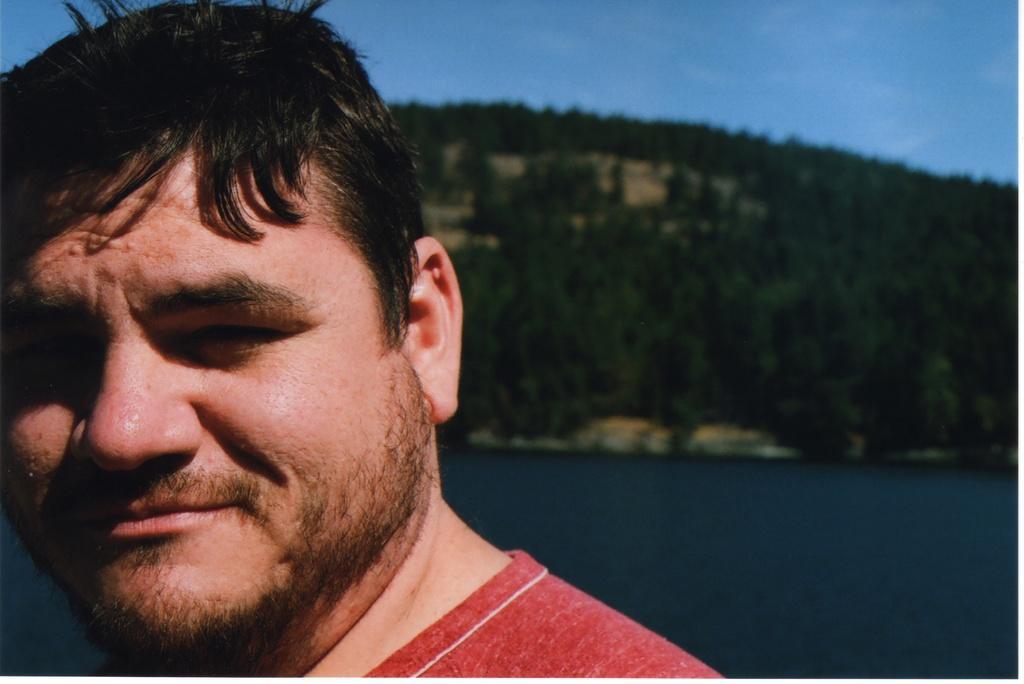Please provide a concise description of this image. In this image in the front there is a person smiling. In the center there is water. In the background there are trees. 